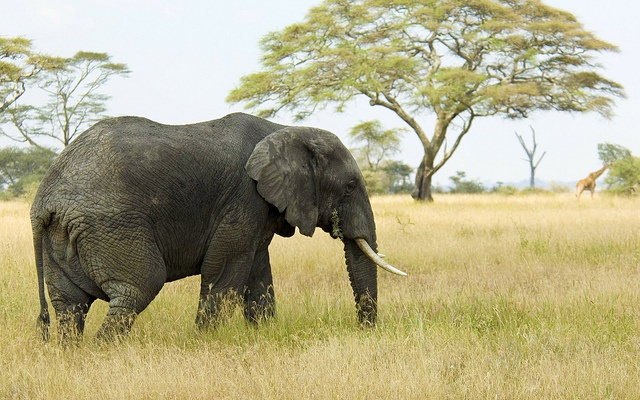Describe the objects in this image and their specific colors. I can see elephant in white, black, gray, darkgreen, and olive tones and giraffe in white and tan tones in this image. 